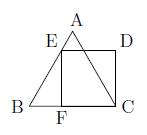Can you explain why the triangle ABC must be equilateral in this diagram? In the diagram, triangle $ABC$ is described as an equilateral triangle, which means that all its sides are of equal length, and all its interior angles are equal, each measuring 60 degrees. This property simplifies calculations and geometrical constructions involving triangle $ABC$ and other shapes such as squares or rectangles within or adjacent to it. 